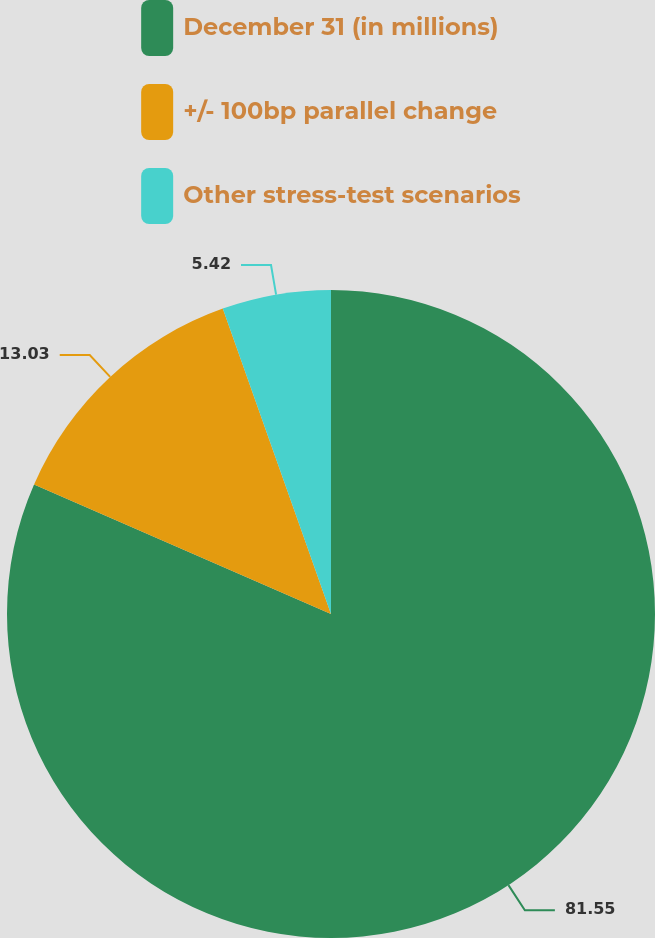Convert chart to OTSL. <chart><loc_0><loc_0><loc_500><loc_500><pie_chart><fcel>December 31 (in millions)<fcel>+/- 100bp parallel change<fcel>Other stress-test scenarios<nl><fcel>81.55%<fcel>13.03%<fcel>5.42%<nl></chart> 